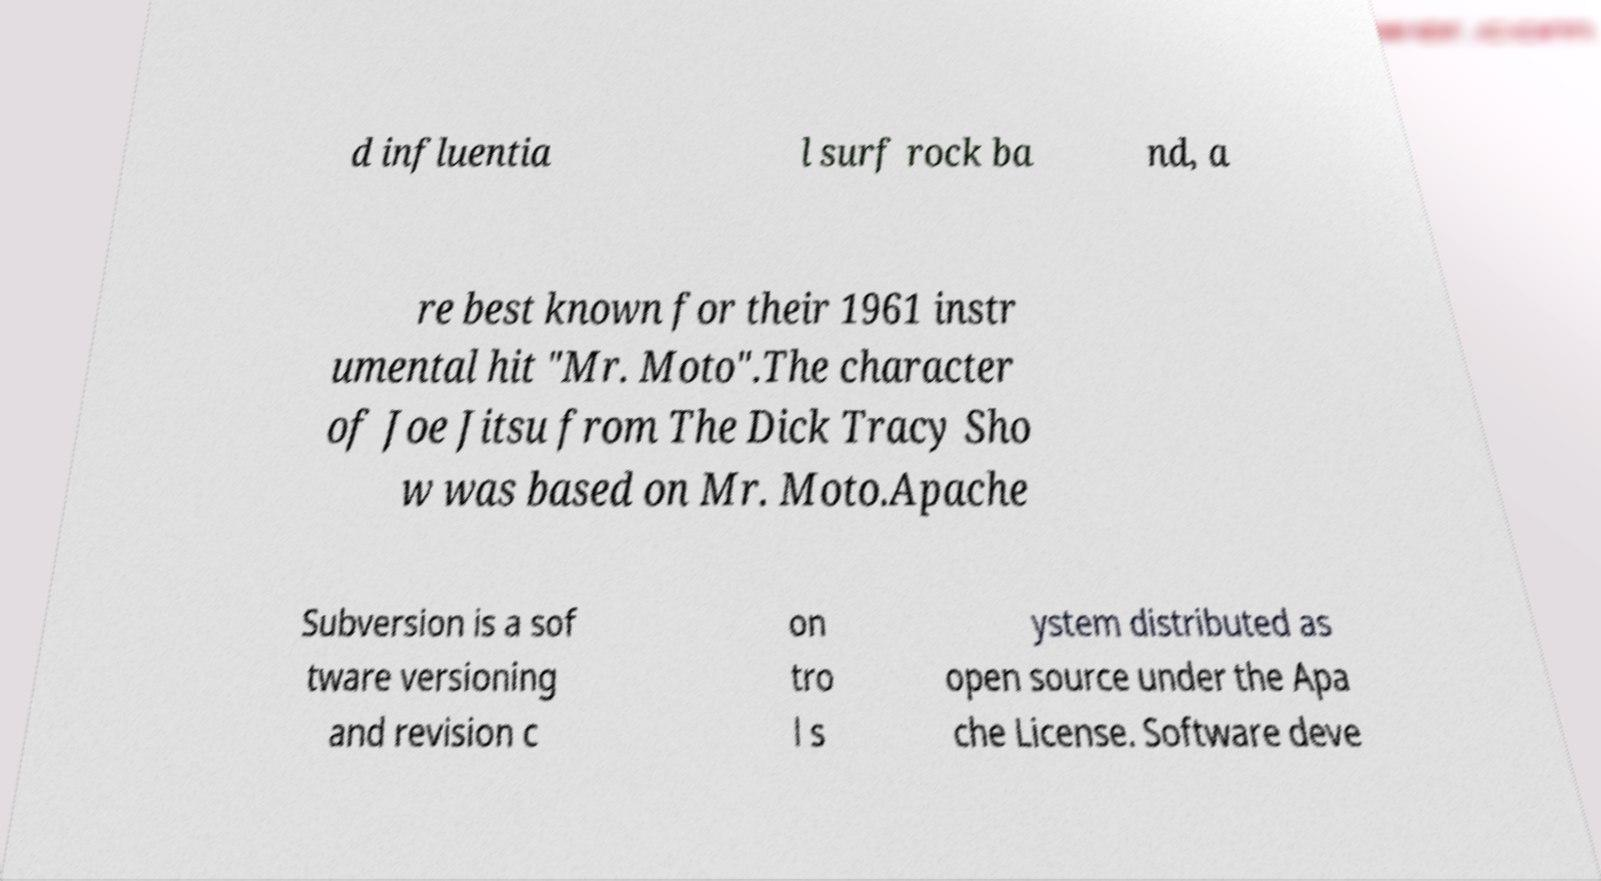Can you read and provide the text displayed in the image?This photo seems to have some interesting text. Can you extract and type it out for me? d influentia l surf rock ba nd, a re best known for their 1961 instr umental hit "Mr. Moto".The character of Joe Jitsu from The Dick Tracy Sho w was based on Mr. Moto.Apache Subversion is a sof tware versioning and revision c on tro l s ystem distributed as open source under the Apa che License. Software deve 